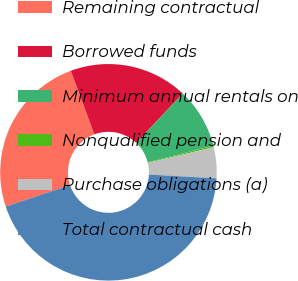Convert chart. <chart><loc_0><loc_0><loc_500><loc_500><pie_chart><fcel>Remaining contractual<fcel>Borrowed funds<fcel>Minimum annual rentals on<fcel>Nonqualified pension and<fcel>Purchase obligations (a)<fcel>Total contractual cash<nl><fcel>24.46%<fcel>17.69%<fcel>8.99%<fcel>0.24%<fcel>4.62%<fcel>43.99%<nl></chart> 